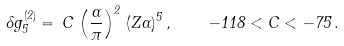Convert formula to latex. <formula><loc_0><loc_0><loc_500><loc_500>\delta g ^ { ( 2 ) } _ { 5 } = \, C \, \left ( \frac { \alpha } { \pi } \right ) ^ { 2 } \, ( Z \alpha ) ^ { 5 } \, , \quad - 1 1 8 < C < - 7 5 \, .</formula> 